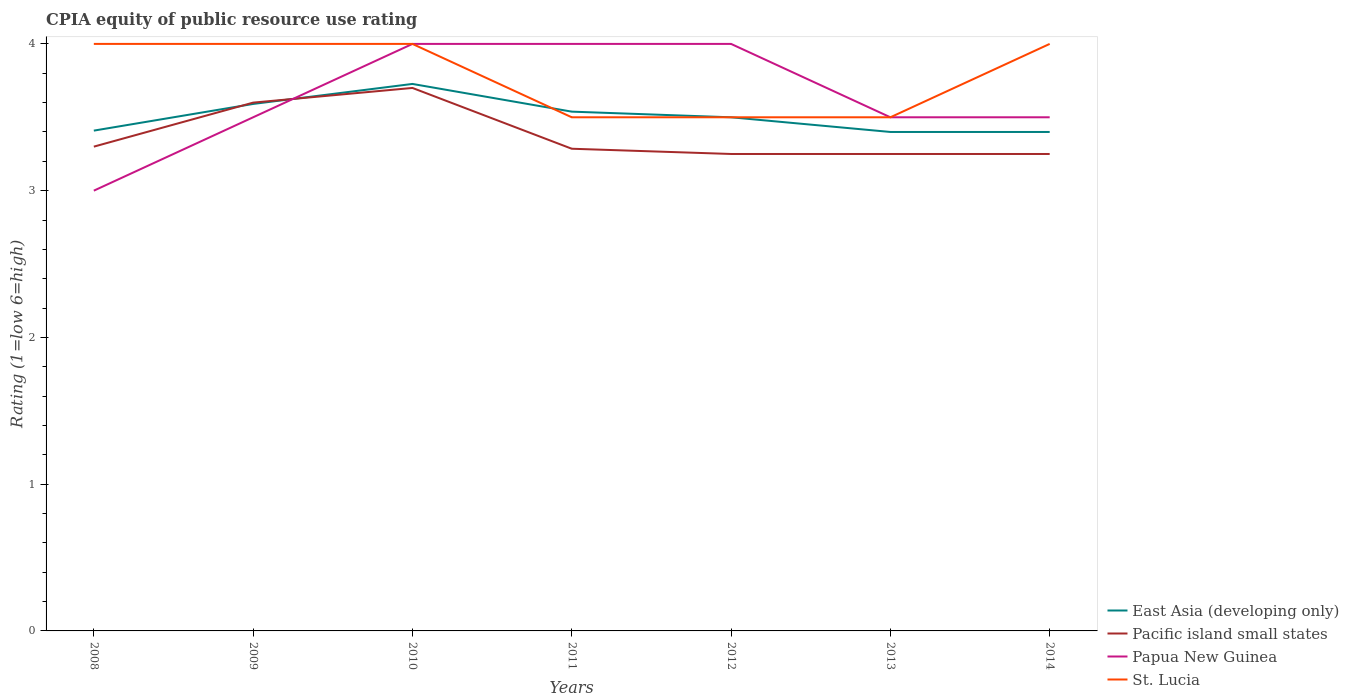How many different coloured lines are there?
Your answer should be very brief. 4. Does the line corresponding to Pacific island small states intersect with the line corresponding to Papua New Guinea?
Keep it short and to the point. Yes. What is the total CPIA rating in Pacific island small states in the graph?
Provide a short and direct response. 0.05. What is the difference between the highest and the second highest CPIA rating in East Asia (developing only)?
Provide a short and direct response. 0.33. What is the difference between the highest and the lowest CPIA rating in Papua New Guinea?
Make the answer very short. 3. Is the CPIA rating in Papua New Guinea strictly greater than the CPIA rating in St. Lucia over the years?
Ensure brevity in your answer.  No. Does the graph contain any zero values?
Provide a succinct answer. No. Does the graph contain grids?
Provide a succinct answer. No. Where does the legend appear in the graph?
Provide a succinct answer. Bottom right. How many legend labels are there?
Give a very brief answer. 4. What is the title of the graph?
Keep it short and to the point. CPIA equity of public resource use rating. What is the label or title of the X-axis?
Ensure brevity in your answer.  Years. What is the label or title of the Y-axis?
Make the answer very short. Rating (1=low 6=high). What is the Rating (1=low 6=high) of East Asia (developing only) in 2008?
Offer a very short reply. 3.41. What is the Rating (1=low 6=high) in Pacific island small states in 2008?
Give a very brief answer. 3.3. What is the Rating (1=low 6=high) in East Asia (developing only) in 2009?
Keep it short and to the point. 3.59. What is the Rating (1=low 6=high) of Pacific island small states in 2009?
Offer a terse response. 3.6. What is the Rating (1=low 6=high) of East Asia (developing only) in 2010?
Provide a succinct answer. 3.73. What is the Rating (1=low 6=high) of Papua New Guinea in 2010?
Provide a succinct answer. 4. What is the Rating (1=low 6=high) of St. Lucia in 2010?
Provide a short and direct response. 4. What is the Rating (1=low 6=high) of East Asia (developing only) in 2011?
Offer a very short reply. 3.54. What is the Rating (1=low 6=high) in Pacific island small states in 2011?
Your answer should be very brief. 3.29. What is the Rating (1=low 6=high) of Papua New Guinea in 2011?
Ensure brevity in your answer.  4. What is the Rating (1=low 6=high) of St. Lucia in 2011?
Give a very brief answer. 3.5. What is the Rating (1=low 6=high) of Pacific island small states in 2012?
Provide a succinct answer. 3.25. What is the Rating (1=low 6=high) of Papua New Guinea in 2012?
Give a very brief answer. 4. What is the Rating (1=low 6=high) of East Asia (developing only) in 2013?
Ensure brevity in your answer.  3.4. What is the Rating (1=low 6=high) in East Asia (developing only) in 2014?
Your answer should be very brief. 3.4. What is the Rating (1=low 6=high) of Papua New Guinea in 2014?
Offer a very short reply. 3.5. What is the Rating (1=low 6=high) in St. Lucia in 2014?
Your answer should be compact. 4. Across all years, what is the maximum Rating (1=low 6=high) of East Asia (developing only)?
Ensure brevity in your answer.  3.73. Across all years, what is the maximum Rating (1=low 6=high) in Pacific island small states?
Keep it short and to the point. 3.7. Across all years, what is the maximum Rating (1=low 6=high) in St. Lucia?
Your response must be concise. 4. Across all years, what is the minimum Rating (1=low 6=high) in East Asia (developing only)?
Offer a very short reply. 3.4. Across all years, what is the minimum Rating (1=low 6=high) of Pacific island small states?
Offer a terse response. 3.25. Across all years, what is the minimum Rating (1=low 6=high) of Papua New Guinea?
Make the answer very short. 3. Across all years, what is the minimum Rating (1=low 6=high) of St. Lucia?
Make the answer very short. 3.5. What is the total Rating (1=low 6=high) of East Asia (developing only) in the graph?
Provide a succinct answer. 24.57. What is the total Rating (1=low 6=high) of Pacific island small states in the graph?
Provide a succinct answer. 23.64. What is the total Rating (1=low 6=high) of St. Lucia in the graph?
Provide a short and direct response. 26.5. What is the difference between the Rating (1=low 6=high) of East Asia (developing only) in 2008 and that in 2009?
Provide a short and direct response. -0.18. What is the difference between the Rating (1=low 6=high) in East Asia (developing only) in 2008 and that in 2010?
Offer a very short reply. -0.32. What is the difference between the Rating (1=low 6=high) of St. Lucia in 2008 and that in 2010?
Your answer should be very brief. 0. What is the difference between the Rating (1=low 6=high) of East Asia (developing only) in 2008 and that in 2011?
Offer a very short reply. -0.13. What is the difference between the Rating (1=low 6=high) of Pacific island small states in 2008 and that in 2011?
Give a very brief answer. 0.01. What is the difference between the Rating (1=low 6=high) in St. Lucia in 2008 and that in 2011?
Keep it short and to the point. 0.5. What is the difference between the Rating (1=low 6=high) in East Asia (developing only) in 2008 and that in 2012?
Offer a terse response. -0.09. What is the difference between the Rating (1=low 6=high) of St. Lucia in 2008 and that in 2012?
Offer a very short reply. 0.5. What is the difference between the Rating (1=low 6=high) in East Asia (developing only) in 2008 and that in 2013?
Provide a short and direct response. 0.01. What is the difference between the Rating (1=low 6=high) of Papua New Guinea in 2008 and that in 2013?
Ensure brevity in your answer.  -0.5. What is the difference between the Rating (1=low 6=high) in St. Lucia in 2008 and that in 2013?
Ensure brevity in your answer.  0.5. What is the difference between the Rating (1=low 6=high) in East Asia (developing only) in 2008 and that in 2014?
Your answer should be compact. 0.01. What is the difference between the Rating (1=low 6=high) of Pacific island small states in 2008 and that in 2014?
Provide a short and direct response. 0.05. What is the difference between the Rating (1=low 6=high) of Papua New Guinea in 2008 and that in 2014?
Give a very brief answer. -0.5. What is the difference between the Rating (1=low 6=high) of East Asia (developing only) in 2009 and that in 2010?
Provide a short and direct response. -0.14. What is the difference between the Rating (1=low 6=high) of Pacific island small states in 2009 and that in 2010?
Your answer should be compact. -0.1. What is the difference between the Rating (1=low 6=high) of Papua New Guinea in 2009 and that in 2010?
Provide a succinct answer. -0.5. What is the difference between the Rating (1=low 6=high) in East Asia (developing only) in 2009 and that in 2011?
Ensure brevity in your answer.  0.05. What is the difference between the Rating (1=low 6=high) in Pacific island small states in 2009 and that in 2011?
Offer a terse response. 0.31. What is the difference between the Rating (1=low 6=high) of St. Lucia in 2009 and that in 2011?
Your answer should be compact. 0.5. What is the difference between the Rating (1=low 6=high) of East Asia (developing only) in 2009 and that in 2012?
Give a very brief answer. 0.09. What is the difference between the Rating (1=low 6=high) of Papua New Guinea in 2009 and that in 2012?
Make the answer very short. -0.5. What is the difference between the Rating (1=low 6=high) in East Asia (developing only) in 2009 and that in 2013?
Keep it short and to the point. 0.19. What is the difference between the Rating (1=low 6=high) in Pacific island small states in 2009 and that in 2013?
Your response must be concise. 0.35. What is the difference between the Rating (1=low 6=high) in East Asia (developing only) in 2009 and that in 2014?
Provide a short and direct response. 0.19. What is the difference between the Rating (1=low 6=high) of Pacific island small states in 2009 and that in 2014?
Offer a terse response. 0.35. What is the difference between the Rating (1=low 6=high) of East Asia (developing only) in 2010 and that in 2011?
Offer a very short reply. 0.19. What is the difference between the Rating (1=low 6=high) of Pacific island small states in 2010 and that in 2011?
Give a very brief answer. 0.41. What is the difference between the Rating (1=low 6=high) in St. Lucia in 2010 and that in 2011?
Your answer should be very brief. 0.5. What is the difference between the Rating (1=low 6=high) of East Asia (developing only) in 2010 and that in 2012?
Offer a very short reply. 0.23. What is the difference between the Rating (1=low 6=high) of Pacific island small states in 2010 and that in 2012?
Offer a terse response. 0.45. What is the difference between the Rating (1=low 6=high) in St. Lucia in 2010 and that in 2012?
Offer a terse response. 0.5. What is the difference between the Rating (1=low 6=high) in East Asia (developing only) in 2010 and that in 2013?
Offer a very short reply. 0.33. What is the difference between the Rating (1=low 6=high) in Pacific island small states in 2010 and that in 2013?
Give a very brief answer. 0.45. What is the difference between the Rating (1=low 6=high) in Papua New Guinea in 2010 and that in 2013?
Your answer should be very brief. 0.5. What is the difference between the Rating (1=low 6=high) of St. Lucia in 2010 and that in 2013?
Offer a terse response. 0.5. What is the difference between the Rating (1=low 6=high) of East Asia (developing only) in 2010 and that in 2014?
Offer a terse response. 0.33. What is the difference between the Rating (1=low 6=high) of Pacific island small states in 2010 and that in 2014?
Provide a short and direct response. 0.45. What is the difference between the Rating (1=low 6=high) in Papua New Guinea in 2010 and that in 2014?
Provide a short and direct response. 0.5. What is the difference between the Rating (1=low 6=high) in St. Lucia in 2010 and that in 2014?
Offer a very short reply. 0. What is the difference between the Rating (1=low 6=high) in East Asia (developing only) in 2011 and that in 2012?
Make the answer very short. 0.04. What is the difference between the Rating (1=low 6=high) in Pacific island small states in 2011 and that in 2012?
Make the answer very short. 0.04. What is the difference between the Rating (1=low 6=high) in East Asia (developing only) in 2011 and that in 2013?
Your response must be concise. 0.14. What is the difference between the Rating (1=low 6=high) in Pacific island small states in 2011 and that in 2013?
Provide a succinct answer. 0.04. What is the difference between the Rating (1=low 6=high) of Papua New Guinea in 2011 and that in 2013?
Your answer should be compact. 0.5. What is the difference between the Rating (1=low 6=high) in East Asia (developing only) in 2011 and that in 2014?
Make the answer very short. 0.14. What is the difference between the Rating (1=low 6=high) of Pacific island small states in 2011 and that in 2014?
Your answer should be compact. 0.04. What is the difference between the Rating (1=low 6=high) in St. Lucia in 2011 and that in 2014?
Your answer should be very brief. -0.5. What is the difference between the Rating (1=low 6=high) of East Asia (developing only) in 2012 and that in 2013?
Provide a short and direct response. 0.1. What is the difference between the Rating (1=low 6=high) in Pacific island small states in 2012 and that in 2013?
Provide a short and direct response. 0. What is the difference between the Rating (1=low 6=high) in East Asia (developing only) in 2012 and that in 2014?
Keep it short and to the point. 0.1. What is the difference between the Rating (1=low 6=high) in Pacific island small states in 2012 and that in 2014?
Give a very brief answer. 0. What is the difference between the Rating (1=low 6=high) of Papua New Guinea in 2012 and that in 2014?
Ensure brevity in your answer.  0.5. What is the difference between the Rating (1=low 6=high) in East Asia (developing only) in 2013 and that in 2014?
Give a very brief answer. 0. What is the difference between the Rating (1=low 6=high) in Pacific island small states in 2013 and that in 2014?
Your response must be concise. 0. What is the difference between the Rating (1=low 6=high) in Papua New Guinea in 2013 and that in 2014?
Keep it short and to the point. 0. What is the difference between the Rating (1=low 6=high) in St. Lucia in 2013 and that in 2014?
Provide a short and direct response. -0.5. What is the difference between the Rating (1=low 6=high) in East Asia (developing only) in 2008 and the Rating (1=low 6=high) in Pacific island small states in 2009?
Ensure brevity in your answer.  -0.19. What is the difference between the Rating (1=low 6=high) of East Asia (developing only) in 2008 and the Rating (1=low 6=high) of Papua New Guinea in 2009?
Your answer should be compact. -0.09. What is the difference between the Rating (1=low 6=high) of East Asia (developing only) in 2008 and the Rating (1=low 6=high) of St. Lucia in 2009?
Your answer should be very brief. -0.59. What is the difference between the Rating (1=low 6=high) of Pacific island small states in 2008 and the Rating (1=low 6=high) of St. Lucia in 2009?
Give a very brief answer. -0.7. What is the difference between the Rating (1=low 6=high) of Papua New Guinea in 2008 and the Rating (1=low 6=high) of St. Lucia in 2009?
Provide a succinct answer. -1. What is the difference between the Rating (1=low 6=high) in East Asia (developing only) in 2008 and the Rating (1=low 6=high) in Pacific island small states in 2010?
Provide a succinct answer. -0.29. What is the difference between the Rating (1=low 6=high) in East Asia (developing only) in 2008 and the Rating (1=low 6=high) in Papua New Guinea in 2010?
Provide a succinct answer. -0.59. What is the difference between the Rating (1=low 6=high) in East Asia (developing only) in 2008 and the Rating (1=low 6=high) in St. Lucia in 2010?
Make the answer very short. -0.59. What is the difference between the Rating (1=low 6=high) of Papua New Guinea in 2008 and the Rating (1=low 6=high) of St. Lucia in 2010?
Provide a succinct answer. -1. What is the difference between the Rating (1=low 6=high) of East Asia (developing only) in 2008 and the Rating (1=low 6=high) of Pacific island small states in 2011?
Your answer should be compact. 0.12. What is the difference between the Rating (1=low 6=high) in East Asia (developing only) in 2008 and the Rating (1=low 6=high) in Papua New Guinea in 2011?
Give a very brief answer. -0.59. What is the difference between the Rating (1=low 6=high) in East Asia (developing only) in 2008 and the Rating (1=low 6=high) in St. Lucia in 2011?
Provide a short and direct response. -0.09. What is the difference between the Rating (1=low 6=high) in Papua New Guinea in 2008 and the Rating (1=low 6=high) in St. Lucia in 2011?
Keep it short and to the point. -0.5. What is the difference between the Rating (1=low 6=high) of East Asia (developing only) in 2008 and the Rating (1=low 6=high) of Pacific island small states in 2012?
Your answer should be very brief. 0.16. What is the difference between the Rating (1=low 6=high) of East Asia (developing only) in 2008 and the Rating (1=low 6=high) of Papua New Guinea in 2012?
Your answer should be compact. -0.59. What is the difference between the Rating (1=low 6=high) of East Asia (developing only) in 2008 and the Rating (1=low 6=high) of St. Lucia in 2012?
Make the answer very short. -0.09. What is the difference between the Rating (1=low 6=high) of Pacific island small states in 2008 and the Rating (1=low 6=high) of St. Lucia in 2012?
Ensure brevity in your answer.  -0.2. What is the difference between the Rating (1=low 6=high) in Papua New Guinea in 2008 and the Rating (1=low 6=high) in St. Lucia in 2012?
Provide a succinct answer. -0.5. What is the difference between the Rating (1=low 6=high) of East Asia (developing only) in 2008 and the Rating (1=low 6=high) of Pacific island small states in 2013?
Make the answer very short. 0.16. What is the difference between the Rating (1=low 6=high) in East Asia (developing only) in 2008 and the Rating (1=low 6=high) in Papua New Guinea in 2013?
Provide a short and direct response. -0.09. What is the difference between the Rating (1=low 6=high) of East Asia (developing only) in 2008 and the Rating (1=low 6=high) of St. Lucia in 2013?
Offer a terse response. -0.09. What is the difference between the Rating (1=low 6=high) of Pacific island small states in 2008 and the Rating (1=low 6=high) of Papua New Guinea in 2013?
Your answer should be compact. -0.2. What is the difference between the Rating (1=low 6=high) in Papua New Guinea in 2008 and the Rating (1=low 6=high) in St. Lucia in 2013?
Your answer should be compact. -0.5. What is the difference between the Rating (1=low 6=high) in East Asia (developing only) in 2008 and the Rating (1=low 6=high) in Pacific island small states in 2014?
Offer a very short reply. 0.16. What is the difference between the Rating (1=low 6=high) of East Asia (developing only) in 2008 and the Rating (1=low 6=high) of Papua New Guinea in 2014?
Offer a terse response. -0.09. What is the difference between the Rating (1=low 6=high) in East Asia (developing only) in 2008 and the Rating (1=low 6=high) in St. Lucia in 2014?
Keep it short and to the point. -0.59. What is the difference between the Rating (1=low 6=high) of Pacific island small states in 2008 and the Rating (1=low 6=high) of Papua New Guinea in 2014?
Give a very brief answer. -0.2. What is the difference between the Rating (1=low 6=high) of Pacific island small states in 2008 and the Rating (1=low 6=high) of St. Lucia in 2014?
Provide a short and direct response. -0.7. What is the difference between the Rating (1=low 6=high) of East Asia (developing only) in 2009 and the Rating (1=low 6=high) of Pacific island small states in 2010?
Your response must be concise. -0.11. What is the difference between the Rating (1=low 6=high) in East Asia (developing only) in 2009 and the Rating (1=low 6=high) in Papua New Guinea in 2010?
Your answer should be compact. -0.41. What is the difference between the Rating (1=low 6=high) of East Asia (developing only) in 2009 and the Rating (1=low 6=high) of St. Lucia in 2010?
Ensure brevity in your answer.  -0.41. What is the difference between the Rating (1=low 6=high) in Pacific island small states in 2009 and the Rating (1=low 6=high) in Papua New Guinea in 2010?
Provide a succinct answer. -0.4. What is the difference between the Rating (1=low 6=high) in Papua New Guinea in 2009 and the Rating (1=low 6=high) in St. Lucia in 2010?
Ensure brevity in your answer.  -0.5. What is the difference between the Rating (1=low 6=high) of East Asia (developing only) in 2009 and the Rating (1=low 6=high) of Pacific island small states in 2011?
Your answer should be very brief. 0.31. What is the difference between the Rating (1=low 6=high) in East Asia (developing only) in 2009 and the Rating (1=low 6=high) in Papua New Guinea in 2011?
Provide a succinct answer. -0.41. What is the difference between the Rating (1=low 6=high) of East Asia (developing only) in 2009 and the Rating (1=low 6=high) of St. Lucia in 2011?
Your response must be concise. 0.09. What is the difference between the Rating (1=low 6=high) of Pacific island small states in 2009 and the Rating (1=low 6=high) of St. Lucia in 2011?
Keep it short and to the point. 0.1. What is the difference between the Rating (1=low 6=high) in East Asia (developing only) in 2009 and the Rating (1=low 6=high) in Pacific island small states in 2012?
Your answer should be very brief. 0.34. What is the difference between the Rating (1=low 6=high) in East Asia (developing only) in 2009 and the Rating (1=low 6=high) in Papua New Guinea in 2012?
Ensure brevity in your answer.  -0.41. What is the difference between the Rating (1=low 6=high) of East Asia (developing only) in 2009 and the Rating (1=low 6=high) of St. Lucia in 2012?
Your answer should be compact. 0.09. What is the difference between the Rating (1=low 6=high) in Pacific island small states in 2009 and the Rating (1=low 6=high) in Papua New Guinea in 2012?
Provide a succinct answer. -0.4. What is the difference between the Rating (1=low 6=high) of Papua New Guinea in 2009 and the Rating (1=low 6=high) of St. Lucia in 2012?
Your answer should be very brief. 0. What is the difference between the Rating (1=low 6=high) of East Asia (developing only) in 2009 and the Rating (1=low 6=high) of Pacific island small states in 2013?
Provide a succinct answer. 0.34. What is the difference between the Rating (1=low 6=high) in East Asia (developing only) in 2009 and the Rating (1=low 6=high) in Papua New Guinea in 2013?
Your response must be concise. 0.09. What is the difference between the Rating (1=low 6=high) of East Asia (developing only) in 2009 and the Rating (1=low 6=high) of St. Lucia in 2013?
Provide a short and direct response. 0.09. What is the difference between the Rating (1=low 6=high) of Papua New Guinea in 2009 and the Rating (1=low 6=high) of St. Lucia in 2013?
Provide a short and direct response. 0. What is the difference between the Rating (1=low 6=high) in East Asia (developing only) in 2009 and the Rating (1=low 6=high) in Pacific island small states in 2014?
Make the answer very short. 0.34. What is the difference between the Rating (1=low 6=high) in East Asia (developing only) in 2009 and the Rating (1=low 6=high) in Papua New Guinea in 2014?
Keep it short and to the point. 0.09. What is the difference between the Rating (1=low 6=high) of East Asia (developing only) in 2009 and the Rating (1=low 6=high) of St. Lucia in 2014?
Keep it short and to the point. -0.41. What is the difference between the Rating (1=low 6=high) in Pacific island small states in 2009 and the Rating (1=low 6=high) in Papua New Guinea in 2014?
Give a very brief answer. 0.1. What is the difference between the Rating (1=low 6=high) in Pacific island small states in 2009 and the Rating (1=low 6=high) in St. Lucia in 2014?
Make the answer very short. -0.4. What is the difference between the Rating (1=low 6=high) in East Asia (developing only) in 2010 and the Rating (1=low 6=high) in Pacific island small states in 2011?
Your response must be concise. 0.44. What is the difference between the Rating (1=low 6=high) of East Asia (developing only) in 2010 and the Rating (1=low 6=high) of Papua New Guinea in 2011?
Keep it short and to the point. -0.27. What is the difference between the Rating (1=low 6=high) in East Asia (developing only) in 2010 and the Rating (1=low 6=high) in St. Lucia in 2011?
Your response must be concise. 0.23. What is the difference between the Rating (1=low 6=high) in East Asia (developing only) in 2010 and the Rating (1=low 6=high) in Pacific island small states in 2012?
Your answer should be compact. 0.48. What is the difference between the Rating (1=low 6=high) in East Asia (developing only) in 2010 and the Rating (1=low 6=high) in Papua New Guinea in 2012?
Your answer should be compact. -0.27. What is the difference between the Rating (1=low 6=high) in East Asia (developing only) in 2010 and the Rating (1=low 6=high) in St. Lucia in 2012?
Ensure brevity in your answer.  0.23. What is the difference between the Rating (1=low 6=high) in Pacific island small states in 2010 and the Rating (1=low 6=high) in Papua New Guinea in 2012?
Provide a short and direct response. -0.3. What is the difference between the Rating (1=low 6=high) in Papua New Guinea in 2010 and the Rating (1=low 6=high) in St. Lucia in 2012?
Your answer should be compact. 0.5. What is the difference between the Rating (1=low 6=high) of East Asia (developing only) in 2010 and the Rating (1=low 6=high) of Pacific island small states in 2013?
Ensure brevity in your answer.  0.48. What is the difference between the Rating (1=low 6=high) of East Asia (developing only) in 2010 and the Rating (1=low 6=high) of Papua New Guinea in 2013?
Provide a succinct answer. 0.23. What is the difference between the Rating (1=low 6=high) in East Asia (developing only) in 2010 and the Rating (1=low 6=high) in St. Lucia in 2013?
Provide a short and direct response. 0.23. What is the difference between the Rating (1=low 6=high) in Pacific island small states in 2010 and the Rating (1=low 6=high) in Papua New Guinea in 2013?
Your response must be concise. 0.2. What is the difference between the Rating (1=low 6=high) in Pacific island small states in 2010 and the Rating (1=low 6=high) in St. Lucia in 2013?
Your response must be concise. 0.2. What is the difference between the Rating (1=low 6=high) in East Asia (developing only) in 2010 and the Rating (1=low 6=high) in Pacific island small states in 2014?
Your answer should be compact. 0.48. What is the difference between the Rating (1=low 6=high) in East Asia (developing only) in 2010 and the Rating (1=low 6=high) in Papua New Guinea in 2014?
Your response must be concise. 0.23. What is the difference between the Rating (1=low 6=high) of East Asia (developing only) in 2010 and the Rating (1=low 6=high) of St. Lucia in 2014?
Offer a very short reply. -0.27. What is the difference between the Rating (1=low 6=high) in Pacific island small states in 2010 and the Rating (1=low 6=high) in Papua New Guinea in 2014?
Offer a terse response. 0.2. What is the difference between the Rating (1=low 6=high) in Pacific island small states in 2010 and the Rating (1=low 6=high) in St. Lucia in 2014?
Provide a short and direct response. -0.3. What is the difference between the Rating (1=low 6=high) of Papua New Guinea in 2010 and the Rating (1=low 6=high) of St. Lucia in 2014?
Ensure brevity in your answer.  0. What is the difference between the Rating (1=low 6=high) in East Asia (developing only) in 2011 and the Rating (1=low 6=high) in Pacific island small states in 2012?
Offer a very short reply. 0.29. What is the difference between the Rating (1=low 6=high) in East Asia (developing only) in 2011 and the Rating (1=low 6=high) in Papua New Guinea in 2012?
Keep it short and to the point. -0.46. What is the difference between the Rating (1=low 6=high) of East Asia (developing only) in 2011 and the Rating (1=low 6=high) of St. Lucia in 2012?
Provide a short and direct response. 0.04. What is the difference between the Rating (1=low 6=high) of Pacific island small states in 2011 and the Rating (1=low 6=high) of Papua New Guinea in 2012?
Make the answer very short. -0.71. What is the difference between the Rating (1=low 6=high) in Pacific island small states in 2011 and the Rating (1=low 6=high) in St. Lucia in 2012?
Provide a short and direct response. -0.21. What is the difference between the Rating (1=low 6=high) of Papua New Guinea in 2011 and the Rating (1=low 6=high) of St. Lucia in 2012?
Your answer should be very brief. 0.5. What is the difference between the Rating (1=low 6=high) of East Asia (developing only) in 2011 and the Rating (1=low 6=high) of Pacific island small states in 2013?
Your response must be concise. 0.29. What is the difference between the Rating (1=low 6=high) of East Asia (developing only) in 2011 and the Rating (1=low 6=high) of Papua New Guinea in 2013?
Keep it short and to the point. 0.04. What is the difference between the Rating (1=low 6=high) of East Asia (developing only) in 2011 and the Rating (1=low 6=high) of St. Lucia in 2013?
Your answer should be compact. 0.04. What is the difference between the Rating (1=low 6=high) of Pacific island small states in 2011 and the Rating (1=low 6=high) of Papua New Guinea in 2013?
Provide a short and direct response. -0.21. What is the difference between the Rating (1=low 6=high) in Pacific island small states in 2011 and the Rating (1=low 6=high) in St. Lucia in 2013?
Keep it short and to the point. -0.21. What is the difference between the Rating (1=low 6=high) in East Asia (developing only) in 2011 and the Rating (1=low 6=high) in Pacific island small states in 2014?
Provide a short and direct response. 0.29. What is the difference between the Rating (1=low 6=high) of East Asia (developing only) in 2011 and the Rating (1=low 6=high) of Papua New Guinea in 2014?
Offer a terse response. 0.04. What is the difference between the Rating (1=low 6=high) in East Asia (developing only) in 2011 and the Rating (1=low 6=high) in St. Lucia in 2014?
Your answer should be compact. -0.46. What is the difference between the Rating (1=low 6=high) of Pacific island small states in 2011 and the Rating (1=low 6=high) of Papua New Guinea in 2014?
Provide a short and direct response. -0.21. What is the difference between the Rating (1=low 6=high) in Pacific island small states in 2011 and the Rating (1=low 6=high) in St. Lucia in 2014?
Ensure brevity in your answer.  -0.71. What is the difference between the Rating (1=low 6=high) in East Asia (developing only) in 2012 and the Rating (1=low 6=high) in Papua New Guinea in 2013?
Make the answer very short. 0. What is the difference between the Rating (1=low 6=high) in East Asia (developing only) in 2012 and the Rating (1=low 6=high) in St. Lucia in 2013?
Give a very brief answer. 0. What is the difference between the Rating (1=low 6=high) of Pacific island small states in 2012 and the Rating (1=low 6=high) of St. Lucia in 2013?
Your answer should be very brief. -0.25. What is the difference between the Rating (1=low 6=high) of East Asia (developing only) in 2012 and the Rating (1=low 6=high) of Pacific island small states in 2014?
Your answer should be compact. 0.25. What is the difference between the Rating (1=low 6=high) of East Asia (developing only) in 2012 and the Rating (1=low 6=high) of St. Lucia in 2014?
Provide a short and direct response. -0.5. What is the difference between the Rating (1=low 6=high) in Pacific island small states in 2012 and the Rating (1=low 6=high) in St. Lucia in 2014?
Make the answer very short. -0.75. What is the difference between the Rating (1=low 6=high) of East Asia (developing only) in 2013 and the Rating (1=low 6=high) of Papua New Guinea in 2014?
Provide a short and direct response. -0.1. What is the difference between the Rating (1=low 6=high) in East Asia (developing only) in 2013 and the Rating (1=low 6=high) in St. Lucia in 2014?
Offer a very short reply. -0.6. What is the difference between the Rating (1=low 6=high) of Pacific island small states in 2013 and the Rating (1=low 6=high) of Papua New Guinea in 2014?
Ensure brevity in your answer.  -0.25. What is the difference between the Rating (1=low 6=high) in Pacific island small states in 2013 and the Rating (1=low 6=high) in St. Lucia in 2014?
Offer a terse response. -0.75. What is the difference between the Rating (1=low 6=high) of Papua New Guinea in 2013 and the Rating (1=low 6=high) of St. Lucia in 2014?
Your answer should be compact. -0.5. What is the average Rating (1=low 6=high) in East Asia (developing only) per year?
Your answer should be compact. 3.51. What is the average Rating (1=low 6=high) in Pacific island small states per year?
Offer a very short reply. 3.38. What is the average Rating (1=low 6=high) of Papua New Guinea per year?
Offer a very short reply. 3.64. What is the average Rating (1=low 6=high) in St. Lucia per year?
Offer a terse response. 3.79. In the year 2008, what is the difference between the Rating (1=low 6=high) in East Asia (developing only) and Rating (1=low 6=high) in Pacific island small states?
Give a very brief answer. 0.11. In the year 2008, what is the difference between the Rating (1=low 6=high) of East Asia (developing only) and Rating (1=low 6=high) of Papua New Guinea?
Make the answer very short. 0.41. In the year 2008, what is the difference between the Rating (1=low 6=high) in East Asia (developing only) and Rating (1=low 6=high) in St. Lucia?
Ensure brevity in your answer.  -0.59. In the year 2008, what is the difference between the Rating (1=low 6=high) of Pacific island small states and Rating (1=low 6=high) of Papua New Guinea?
Your response must be concise. 0.3. In the year 2008, what is the difference between the Rating (1=low 6=high) of Pacific island small states and Rating (1=low 6=high) of St. Lucia?
Provide a succinct answer. -0.7. In the year 2008, what is the difference between the Rating (1=low 6=high) of Papua New Guinea and Rating (1=low 6=high) of St. Lucia?
Ensure brevity in your answer.  -1. In the year 2009, what is the difference between the Rating (1=low 6=high) in East Asia (developing only) and Rating (1=low 6=high) in Pacific island small states?
Your response must be concise. -0.01. In the year 2009, what is the difference between the Rating (1=low 6=high) of East Asia (developing only) and Rating (1=low 6=high) of Papua New Guinea?
Offer a very short reply. 0.09. In the year 2009, what is the difference between the Rating (1=low 6=high) in East Asia (developing only) and Rating (1=low 6=high) in St. Lucia?
Offer a terse response. -0.41. In the year 2009, what is the difference between the Rating (1=low 6=high) of Pacific island small states and Rating (1=low 6=high) of Papua New Guinea?
Provide a succinct answer. 0.1. In the year 2009, what is the difference between the Rating (1=low 6=high) of Pacific island small states and Rating (1=low 6=high) of St. Lucia?
Your answer should be very brief. -0.4. In the year 2010, what is the difference between the Rating (1=low 6=high) of East Asia (developing only) and Rating (1=low 6=high) of Pacific island small states?
Ensure brevity in your answer.  0.03. In the year 2010, what is the difference between the Rating (1=low 6=high) of East Asia (developing only) and Rating (1=low 6=high) of Papua New Guinea?
Provide a succinct answer. -0.27. In the year 2010, what is the difference between the Rating (1=low 6=high) in East Asia (developing only) and Rating (1=low 6=high) in St. Lucia?
Ensure brevity in your answer.  -0.27. In the year 2010, what is the difference between the Rating (1=low 6=high) in Pacific island small states and Rating (1=low 6=high) in Papua New Guinea?
Keep it short and to the point. -0.3. In the year 2010, what is the difference between the Rating (1=low 6=high) in Pacific island small states and Rating (1=low 6=high) in St. Lucia?
Your answer should be very brief. -0.3. In the year 2010, what is the difference between the Rating (1=low 6=high) in Papua New Guinea and Rating (1=low 6=high) in St. Lucia?
Ensure brevity in your answer.  0. In the year 2011, what is the difference between the Rating (1=low 6=high) in East Asia (developing only) and Rating (1=low 6=high) in Pacific island small states?
Your response must be concise. 0.25. In the year 2011, what is the difference between the Rating (1=low 6=high) in East Asia (developing only) and Rating (1=low 6=high) in Papua New Guinea?
Ensure brevity in your answer.  -0.46. In the year 2011, what is the difference between the Rating (1=low 6=high) of East Asia (developing only) and Rating (1=low 6=high) of St. Lucia?
Your response must be concise. 0.04. In the year 2011, what is the difference between the Rating (1=low 6=high) of Pacific island small states and Rating (1=low 6=high) of Papua New Guinea?
Ensure brevity in your answer.  -0.71. In the year 2011, what is the difference between the Rating (1=low 6=high) in Pacific island small states and Rating (1=low 6=high) in St. Lucia?
Your answer should be very brief. -0.21. In the year 2011, what is the difference between the Rating (1=low 6=high) of Papua New Guinea and Rating (1=low 6=high) of St. Lucia?
Provide a succinct answer. 0.5. In the year 2012, what is the difference between the Rating (1=low 6=high) of East Asia (developing only) and Rating (1=low 6=high) of Pacific island small states?
Offer a very short reply. 0.25. In the year 2012, what is the difference between the Rating (1=low 6=high) of East Asia (developing only) and Rating (1=low 6=high) of Papua New Guinea?
Keep it short and to the point. -0.5. In the year 2012, what is the difference between the Rating (1=low 6=high) in Pacific island small states and Rating (1=low 6=high) in Papua New Guinea?
Keep it short and to the point. -0.75. In the year 2012, what is the difference between the Rating (1=low 6=high) of Papua New Guinea and Rating (1=low 6=high) of St. Lucia?
Your answer should be very brief. 0.5. In the year 2013, what is the difference between the Rating (1=low 6=high) of East Asia (developing only) and Rating (1=low 6=high) of Papua New Guinea?
Keep it short and to the point. -0.1. In the year 2013, what is the difference between the Rating (1=low 6=high) in East Asia (developing only) and Rating (1=low 6=high) in St. Lucia?
Your answer should be very brief. -0.1. In the year 2013, what is the difference between the Rating (1=low 6=high) in Pacific island small states and Rating (1=low 6=high) in St. Lucia?
Keep it short and to the point. -0.25. In the year 2013, what is the difference between the Rating (1=low 6=high) of Papua New Guinea and Rating (1=low 6=high) of St. Lucia?
Your response must be concise. 0. In the year 2014, what is the difference between the Rating (1=low 6=high) in East Asia (developing only) and Rating (1=low 6=high) in Papua New Guinea?
Your response must be concise. -0.1. In the year 2014, what is the difference between the Rating (1=low 6=high) of East Asia (developing only) and Rating (1=low 6=high) of St. Lucia?
Your response must be concise. -0.6. In the year 2014, what is the difference between the Rating (1=low 6=high) in Pacific island small states and Rating (1=low 6=high) in St. Lucia?
Provide a succinct answer. -0.75. What is the ratio of the Rating (1=low 6=high) in East Asia (developing only) in 2008 to that in 2009?
Ensure brevity in your answer.  0.95. What is the ratio of the Rating (1=low 6=high) in St. Lucia in 2008 to that in 2009?
Your response must be concise. 1. What is the ratio of the Rating (1=low 6=high) of East Asia (developing only) in 2008 to that in 2010?
Provide a succinct answer. 0.91. What is the ratio of the Rating (1=low 6=high) of Pacific island small states in 2008 to that in 2010?
Your answer should be very brief. 0.89. What is the ratio of the Rating (1=low 6=high) in Papua New Guinea in 2008 to that in 2010?
Your response must be concise. 0.75. What is the ratio of the Rating (1=low 6=high) of St. Lucia in 2008 to that in 2010?
Provide a short and direct response. 1. What is the ratio of the Rating (1=low 6=high) of East Asia (developing only) in 2008 to that in 2011?
Provide a short and direct response. 0.96. What is the ratio of the Rating (1=low 6=high) of Papua New Guinea in 2008 to that in 2011?
Provide a succinct answer. 0.75. What is the ratio of the Rating (1=low 6=high) of Pacific island small states in 2008 to that in 2012?
Offer a very short reply. 1.02. What is the ratio of the Rating (1=low 6=high) of Papua New Guinea in 2008 to that in 2012?
Offer a very short reply. 0.75. What is the ratio of the Rating (1=low 6=high) in St. Lucia in 2008 to that in 2012?
Keep it short and to the point. 1.14. What is the ratio of the Rating (1=low 6=high) in East Asia (developing only) in 2008 to that in 2013?
Keep it short and to the point. 1. What is the ratio of the Rating (1=low 6=high) of Pacific island small states in 2008 to that in 2013?
Your response must be concise. 1.02. What is the ratio of the Rating (1=low 6=high) in St. Lucia in 2008 to that in 2013?
Keep it short and to the point. 1.14. What is the ratio of the Rating (1=low 6=high) in East Asia (developing only) in 2008 to that in 2014?
Your response must be concise. 1. What is the ratio of the Rating (1=low 6=high) in Pacific island small states in 2008 to that in 2014?
Provide a succinct answer. 1.02. What is the ratio of the Rating (1=low 6=high) of East Asia (developing only) in 2009 to that in 2010?
Ensure brevity in your answer.  0.96. What is the ratio of the Rating (1=low 6=high) in East Asia (developing only) in 2009 to that in 2011?
Make the answer very short. 1.01. What is the ratio of the Rating (1=low 6=high) in Pacific island small states in 2009 to that in 2011?
Your response must be concise. 1.1. What is the ratio of the Rating (1=low 6=high) in Papua New Guinea in 2009 to that in 2011?
Provide a short and direct response. 0.88. What is the ratio of the Rating (1=low 6=high) in St. Lucia in 2009 to that in 2011?
Give a very brief answer. 1.14. What is the ratio of the Rating (1=low 6=high) in Pacific island small states in 2009 to that in 2012?
Your answer should be compact. 1.11. What is the ratio of the Rating (1=low 6=high) in Papua New Guinea in 2009 to that in 2012?
Provide a short and direct response. 0.88. What is the ratio of the Rating (1=low 6=high) in St. Lucia in 2009 to that in 2012?
Keep it short and to the point. 1.14. What is the ratio of the Rating (1=low 6=high) of East Asia (developing only) in 2009 to that in 2013?
Your answer should be very brief. 1.06. What is the ratio of the Rating (1=low 6=high) in Pacific island small states in 2009 to that in 2013?
Provide a short and direct response. 1.11. What is the ratio of the Rating (1=low 6=high) in Papua New Guinea in 2009 to that in 2013?
Ensure brevity in your answer.  1. What is the ratio of the Rating (1=low 6=high) of St. Lucia in 2009 to that in 2013?
Make the answer very short. 1.14. What is the ratio of the Rating (1=low 6=high) in East Asia (developing only) in 2009 to that in 2014?
Offer a terse response. 1.06. What is the ratio of the Rating (1=low 6=high) of Pacific island small states in 2009 to that in 2014?
Your answer should be very brief. 1.11. What is the ratio of the Rating (1=low 6=high) in Papua New Guinea in 2009 to that in 2014?
Provide a succinct answer. 1. What is the ratio of the Rating (1=low 6=high) of East Asia (developing only) in 2010 to that in 2011?
Ensure brevity in your answer.  1.05. What is the ratio of the Rating (1=low 6=high) of Pacific island small states in 2010 to that in 2011?
Your answer should be very brief. 1.13. What is the ratio of the Rating (1=low 6=high) of Papua New Guinea in 2010 to that in 2011?
Provide a short and direct response. 1. What is the ratio of the Rating (1=low 6=high) in St. Lucia in 2010 to that in 2011?
Keep it short and to the point. 1.14. What is the ratio of the Rating (1=low 6=high) of East Asia (developing only) in 2010 to that in 2012?
Give a very brief answer. 1.06. What is the ratio of the Rating (1=low 6=high) of Pacific island small states in 2010 to that in 2012?
Offer a very short reply. 1.14. What is the ratio of the Rating (1=low 6=high) in Papua New Guinea in 2010 to that in 2012?
Make the answer very short. 1. What is the ratio of the Rating (1=low 6=high) of St. Lucia in 2010 to that in 2012?
Your response must be concise. 1.14. What is the ratio of the Rating (1=low 6=high) of East Asia (developing only) in 2010 to that in 2013?
Offer a very short reply. 1.1. What is the ratio of the Rating (1=low 6=high) of Pacific island small states in 2010 to that in 2013?
Keep it short and to the point. 1.14. What is the ratio of the Rating (1=low 6=high) in Papua New Guinea in 2010 to that in 2013?
Offer a terse response. 1.14. What is the ratio of the Rating (1=low 6=high) of East Asia (developing only) in 2010 to that in 2014?
Keep it short and to the point. 1.1. What is the ratio of the Rating (1=low 6=high) of Pacific island small states in 2010 to that in 2014?
Your answer should be compact. 1.14. What is the ratio of the Rating (1=low 6=high) of St. Lucia in 2010 to that in 2014?
Your response must be concise. 1. What is the ratio of the Rating (1=low 6=high) in Pacific island small states in 2011 to that in 2012?
Your response must be concise. 1.01. What is the ratio of the Rating (1=low 6=high) of St. Lucia in 2011 to that in 2012?
Keep it short and to the point. 1. What is the ratio of the Rating (1=low 6=high) in East Asia (developing only) in 2011 to that in 2013?
Provide a succinct answer. 1.04. What is the ratio of the Rating (1=low 6=high) in Pacific island small states in 2011 to that in 2013?
Offer a terse response. 1.01. What is the ratio of the Rating (1=low 6=high) in Papua New Guinea in 2011 to that in 2013?
Offer a terse response. 1.14. What is the ratio of the Rating (1=low 6=high) in East Asia (developing only) in 2011 to that in 2014?
Your answer should be very brief. 1.04. What is the ratio of the Rating (1=low 6=high) in East Asia (developing only) in 2012 to that in 2013?
Your answer should be very brief. 1.03. What is the ratio of the Rating (1=low 6=high) in Pacific island small states in 2012 to that in 2013?
Offer a very short reply. 1. What is the ratio of the Rating (1=low 6=high) of Papua New Guinea in 2012 to that in 2013?
Your response must be concise. 1.14. What is the ratio of the Rating (1=low 6=high) in St. Lucia in 2012 to that in 2013?
Your answer should be very brief. 1. What is the ratio of the Rating (1=low 6=high) of East Asia (developing only) in 2012 to that in 2014?
Keep it short and to the point. 1.03. What is the ratio of the Rating (1=low 6=high) in Papua New Guinea in 2012 to that in 2014?
Provide a succinct answer. 1.14. What is the ratio of the Rating (1=low 6=high) in East Asia (developing only) in 2013 to that in 2014?
Your answer should be very brief. 1. What is the ratio of the Rating (1=low 6=high) of Papua New Guinea in 2013 to that in 2014?
Keep it short and to the point. 1. What is the ratio of the Rating (1=low 6=high) of St. Lucia in 2013 to that in 2014?
Your answer should be compact. 0.88. What is the difference between the highest and the second highest Rating (1=low 6=high) of East Asia (developing only)?
Provide a short and direct response. 0.14. What is the difference between the highest and the second highest Rating (1=low 6=high) of Pacific island small states?
Your answer should be compact. 0.1. What is the difference between the highest and the second highest Rating (1=low 6=high) in St. Lucia?
Provide a short and direct response. 0. What is the difference between the highest and the lowest Rating (1=low 6=high) in East Asia (developing only)?
Give a very brief answer. 0.33. What is the difference between the highest and the lowest Rating (1=low 6=high) in Pacific island small states?
Offer a very short reply. 0.45. What is the difference between the highest and the lowest Rating (1=low 6=high) of St. Lucia?
Give a very brief answer. 0.5. 